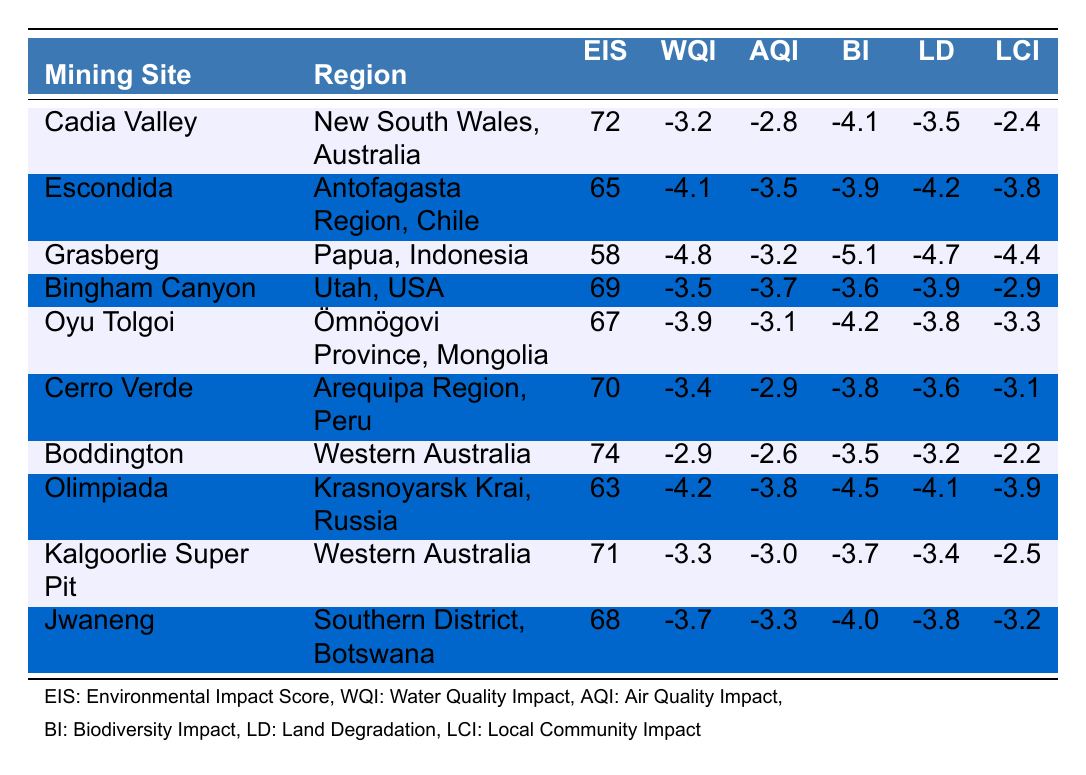What is the Environmental Impact Score of Cadia Valley? The Environmental Impact Score for Cadia Valley is directly listed in the table as 72.
Answer: 72 Which mining site has the lowest Air Quality Impact? The mining site with the lowest Air Quality Impact is Boddington, with a value of -2.6.
Answer: Boddington What is the average Environmental Impact Score of the mining sites in Western Australia? The Environmental Impact Scores for the Western Australian sites (Boddington and Kalgoorlie Super Pit) are 74 and 71, respectively. The average is (74 + 71) / 2 = 72.5.
Answer: 72.5 Does the Grasberg mining site have a higher Water Quality Impact than the Escondida site? The Water Quality Impact for Grasberg is -4.8, while for Escondida, it is -4.1. Since -4.8 is less than -4.1, Grasberg has a lower (more negative) Water Quality Impact.
Answer: No Which site has the highest Biodiversity Impact score? The site with the highest Biodiversity Impact score is Grasberg, which has a score of -5.1.
Answer: Grasberg What is the total Local Community Impact for the sites in Australia? The Local Community Impact scores for the Australian sites Cadia Valley, Bingham Canyon, and both Boddington and Kalgoorlie Super Pit are -2.4, -2.9, -2.2, and -2.5, respectively. Adding them gives: (-2.4) + (-2.9) + (-2.2) + (-2.5) = -10.
Answer: -10 Which region has the highest overall Environmental Impact Score? Comparing the Environmental Impact Scores: Cadia Valley (72), Boddington (74), Kalgoorlie Super Pit (71), and others; Boddington has the highest score of 74.
Answer: Western Australia Is the Local Community Impact score for Olimpiada worse than that of Oyu Tolgoi? The Local Community Impact for Olimpiada is -3.9, while for Oyu Tolgoi it is -3.3. Since -3.9 is less than -3.3, Olimpiada has a worse (more negative) impact.
Answer: Yes What is the difference in Environmental Impact Scores between the best and worst rated sites? The highest score is Boddington at 74, and the lowest is Grasberg at 58. The difference is 74 - 58 = 16.
Answer: 16 Which mining site’s Water Quality Impact is closest to zero? The site with a Water Quality Impact closest to zero is Boddington, which has a score of -2.9.
Answer: Boddington 